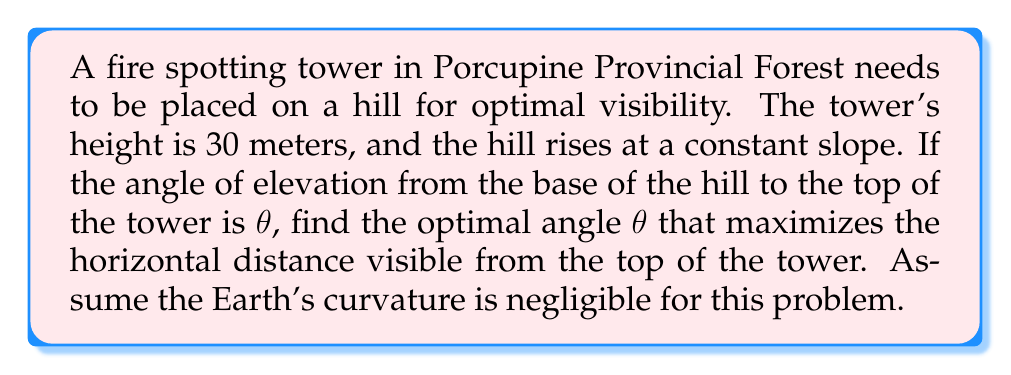Give your solution to this math problem. Let's approach this step-by-step:

1) Let $x$ be the horizontal distance from the base of the hill to the tower, and $h$ be the height of the hill at the tower's location.

2) The total height of the observation point is $h + 30$ (hill height plus tower height).

3) The horizontal distance visible from the top of the tower, $d$, can be expressed as:

   $d = x + \sqrt{2R(h+30)}$

   where $R$ is the Earth's radius (which we'll treat as a constant).

4) We need to express $h$ in terms of $x$ and $\theta$:

   $\tan\theta = \frac{h+30}{x}$
   $h = x\tan\theta - 30$

5) Substituting this into our equation for $d$:

   $d = x + \sqrt{2R(x\tan\theta - 30 + 30)} = x + \sqrt{2Rx\tan\theta}$

6) To find the maximum, we differentiate $d$ with respect to $x$ and set it to zero:

   $$\frac{dd}{dx} = 1 + \frac{R\tan\theta}{\sqrt{2Rx\tan\theta}} = 0$$

7) Solving this equation:

   $\sqrt{2Rx\tan\theta} = R\tan\theta$
   $2Rx\tan\theta = R^2\tan^2\theta$
   $x = \frac{R\tan\theta}{2}$

8) Now, recall that $\tan\theta = \frac{h+30}{x}$. Substituting our result for $x$:

   $\tan\theta = \frac{h+30}{\frac{R\tan\theta}{2}}$

9) Simplifying:

   $\tan^2\theta = \frac{2(h+30)}{R}$

10) The optimal angle occurs when $h = x\tan\theta - 30$. Substituting this and our result for $x$:

    $\tan^2\theta = \frac{2(\frac{R\tan\theta}{2}\tan\theta - 30 + 30)}{R} = \tan^2\theta$

11) This equation is always true, regardless of the value of $\theta$. This means that the optimal angle is when $x = h$, i.e., when the horizontal distance to the tower is equal to the height of the hill.

12) In this case, $\tan\theta = 1$, so the optimal angle $\theta = 45°$.
Answer: $45°$ 